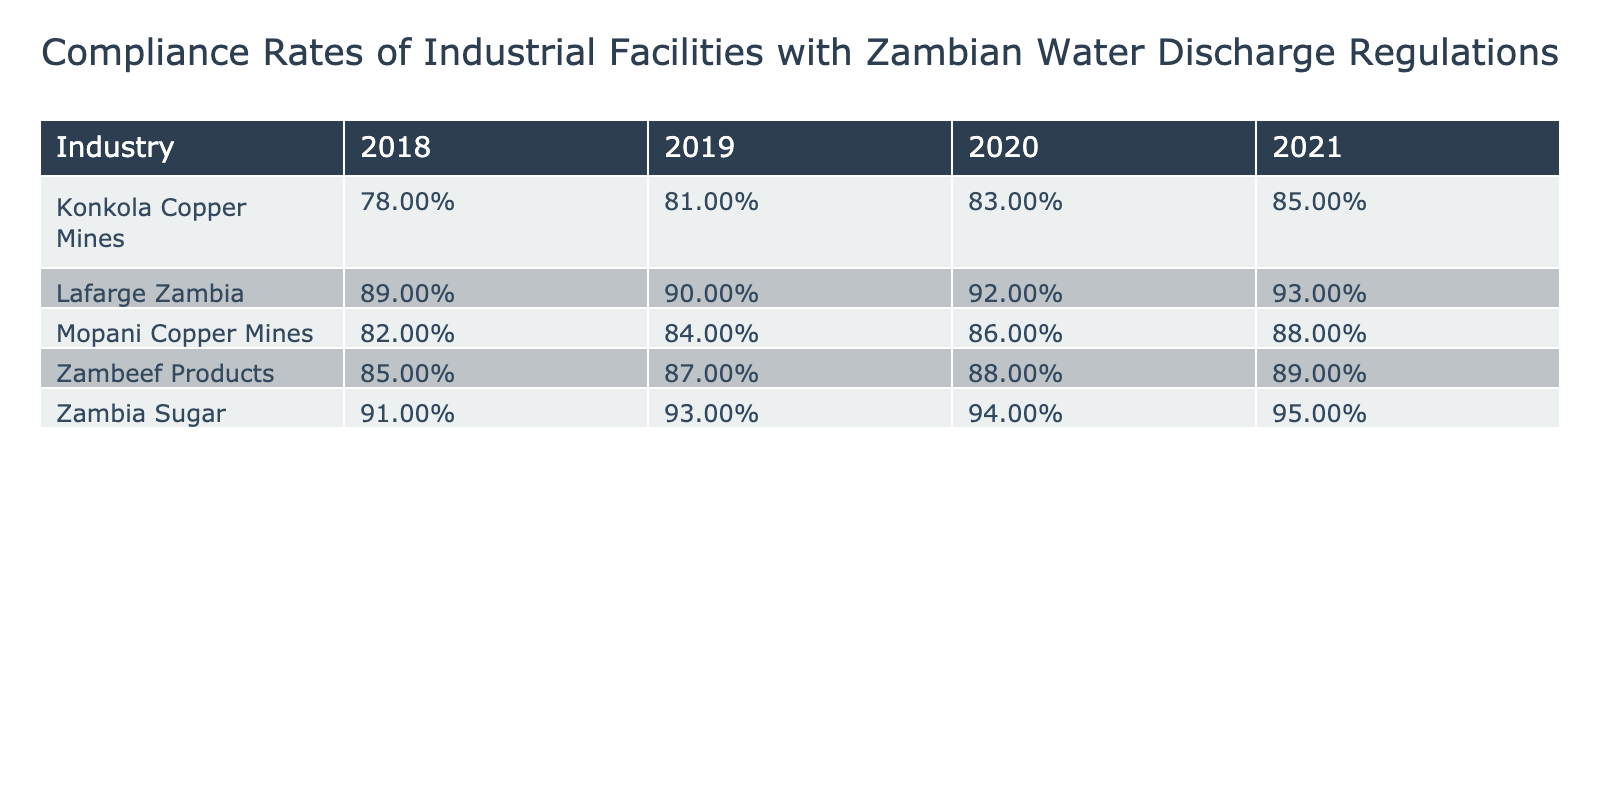What was the compliance rate for Zambia Sugar in 2019? The table shows the compliance rate for Zambia Sugar in 2019 in the corresponding cell, which is 0.93.
Answer: 0.93 Which industry had the highest compliance rate in 2020? Looking at the values in the 2020 column, Zambia Sugar (0.94) has the highest compliance rate compared to other industries.
Answer: Zambia Sugar What is the average compliance rate for Konkola Copper Mines over the four years? To find the average compliance rate, sum the compliance rates for Konkola Copper Mines over the years (0.78 + 0.81 + 0.83 + 0.85) = 3.27, and divide by the number of years (4), which gives 3.27 / 4 = 0.8175.
Answer: 0.82 Did any industry maintain a compliance rate above 0.90 every year? Reviewing the table reveals that Zambia Sugar has compliance rates of 0.91, 0.93, 0.94, and 0.95, which are all above 0.90, thus confirming the statement is true.
Answer: Yes What is the overall trend in compliance rates for Mopani Copper Mines from 2018 to 2021? Analyzing the values for Mopani Copper Mines shows rates of 0.82, 0.84, 0.86, and 0.88, indicating a consistent increase over the four years.
Answer: Increasing Which industry showed the least improvement in compliance from 2018 to 2021? The compliance rates for Zambeef Products in 2018 was 0.85 and in 2021 was 0.89, resulting in an improvement of 0.04. Other industries exhibited greater increases.
Answer: Zambeef Products What is the difference in compliance rates of Lafarge Zambia between 2018 and 2021? The compliance rate for Lafarge Zambia in 2018 was 0.89 and in 2021 it was 0.93. The difference is 0.93 - 0.89 = 0.04.
Answer: 0.04 Which year had the lowest compliance rate for Konkola Copper Mines? By analyzing the compliance rates for Konkola Copper Mines across the years 2018 (0.78), 2019 (0.81), 2020 (0.83), and 2021 (0.85), we can see that 2018 had the lowest at 0.78.
Answer: 2018 What was the total compliance rate for all industries in 2019? Adding the compliance rates for all industries in 2019: 0.82 (Mopani) + 0.93 (Zambia Sugar) + 0.87 (Zambeef) + 0.90 (Lafarge) + 0.84 (Konkola) gives a total of 4.36.
Answer: 4.36 Which industry had the lowest compliance rate in 2019? The compliance rates in 2019 were 0.84 (Konkola), 0.82 (Mopani), 0.93 (Zambia Sugar), 0.87 (Zambeef), and 0.90 (Lafarge). The lowest is 0.82 from Mopani Copper Mines.
Answer: Mopani Copper Mines 